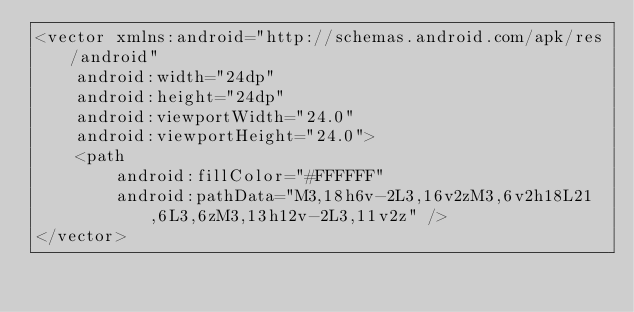<code> <loc_0><loc_0><loc_500><loc_500><_XML_><vector xmlns:android="http://schemas.android.com/apk/res/android"
    android:width="24dp"
    android:height="24dp"
    android:viewportWidth="24.0"
    android:viewportHeight="24.0">
    <path
        android:fillColor="#FFFFFF"
        android:pathData="M3,18h6v-2L3,16v2zM3,6v2h18L21,6L3,6zM3,13h12v-2L3,11v2z" />
</vector>
</code> 